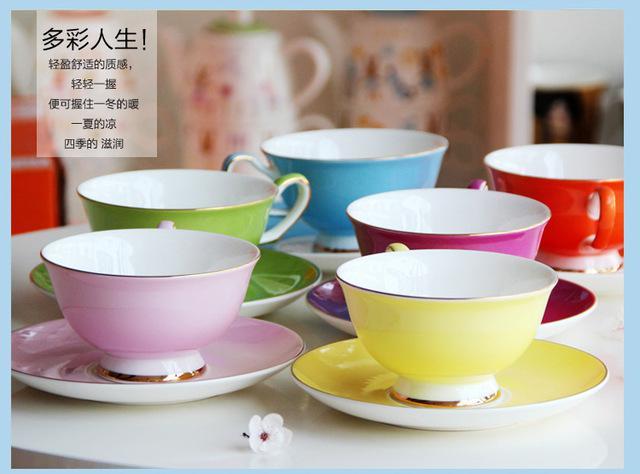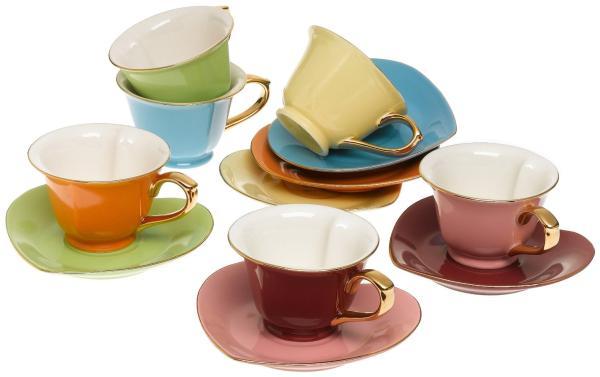The first image is the image on the left, the second image is the image on the right. Given the left and right images, does the statement "At least 4 cups are each placed on top of matching colored plates." hold true? Answer yes or no. Yes. 